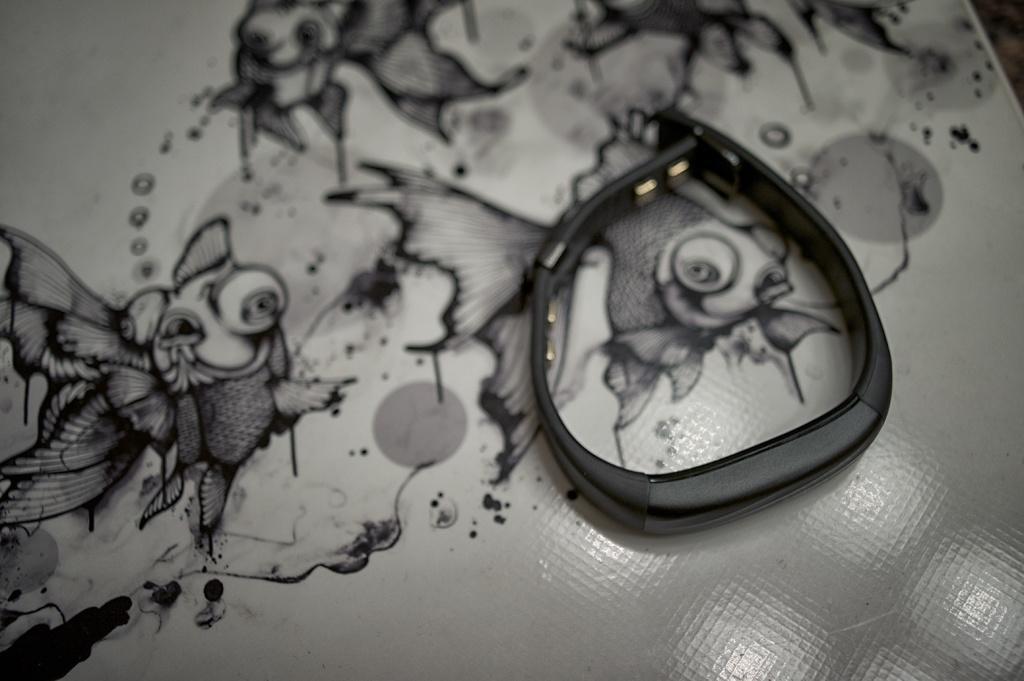Can you describe this image briefly? In this image I can see a fitbit which is placed on a white color sheet. On this sheet I can see some paintings. 